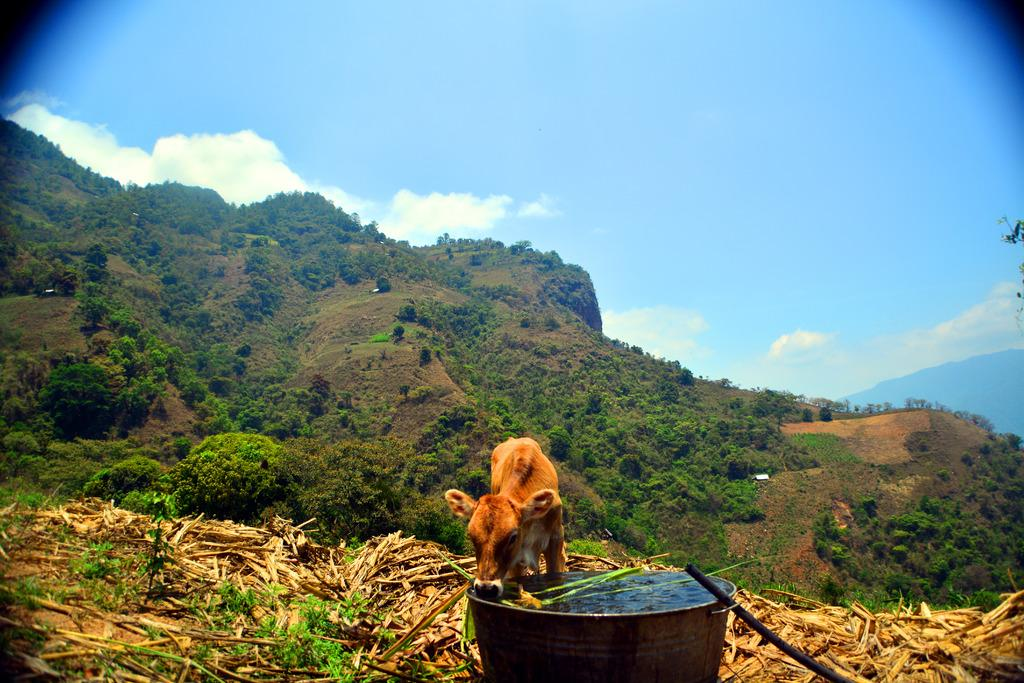What can be seen in the middle of the image? There are trees in the middle of the image. What is visible at the top of the image? There is sky visible at the top of the image. What is located at the bottom of the image? There is a container at the bottom of the image. What is inside the container? There is water in the container. What animal is present in the image? There is a cow in the image. What is the cow doing in the image? The cow is drinking the water from the container. What type of fish can be seen swimming in the water in the image? There are no fish present in the image; it features a cow drinking water from a container. Is there a committee meeting taking place in the image? There is no mention of a committee or meeting in the image, which shows a cow drinking water from a container. 